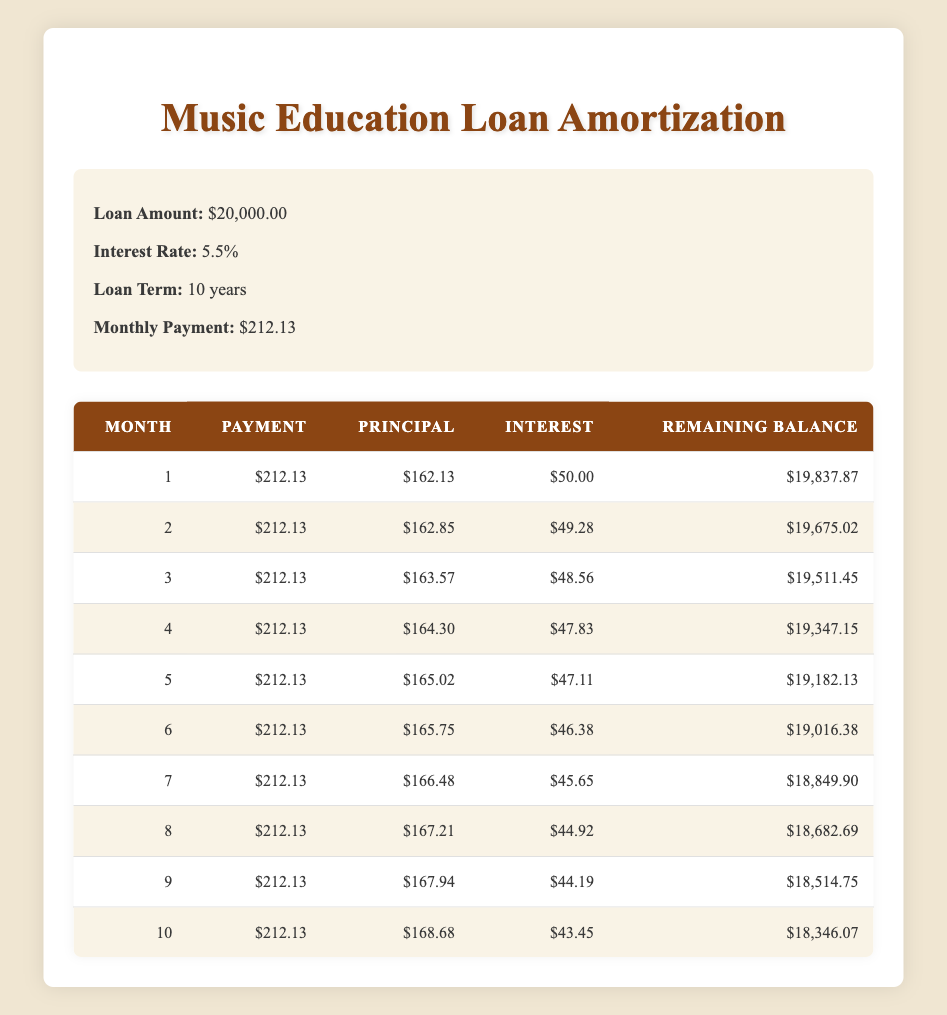What is the total loan amount? The loan amount provided at the beginning of the table states that it is $20,000.
Answer: 20,000.00 What is the interest rate on the loan? The interest rate given in the loan details section is 5.5%.
Answer: 5.5% How much was the principal paid in the first month? Referring to the first row of the table, the principal paid in the first month is $162.13.
Answer: 162.13 What is the remaining balance after the fifth month? Looking at the fifth month’s row in the table, the remaining balance after the fifth month is $19,182.13.
Answer: 19,182.13 What is the total interest paid in the first three months? The interest paid in the first three months is $50.00 + $49.28 + $48.56 = $147.84.
Answer: 147.84 Did the interest paid in the second month decrease compared to the first month? The interest paid in the first month is $50.00 and in the second month it is $49.28, so it did decrease.
Answer: Yes What is the difference in principal payment between the first and third months? In the first month, the principal payment is $162.13 and in the third month it is $163.57. The difference is $163.57 - $162.13 = $1.44.
Answer: 1.44 What is the average monthly payment over the first ten months? The monthly payment is constant at $212.13 for ten months. Therefore, the average is $212.13.
Answer: 212.13 Which month has the lowest interest payment, and what is the amount? The ninth month has the lowest interest payment of $44.19, comparing it with the other months.
Answer: 44.19 What is the remaining balance at the end of the tenth month? The remaining balance after the tenth month is displayed in the table as $18,346.07.
Answer: 18,346.07 